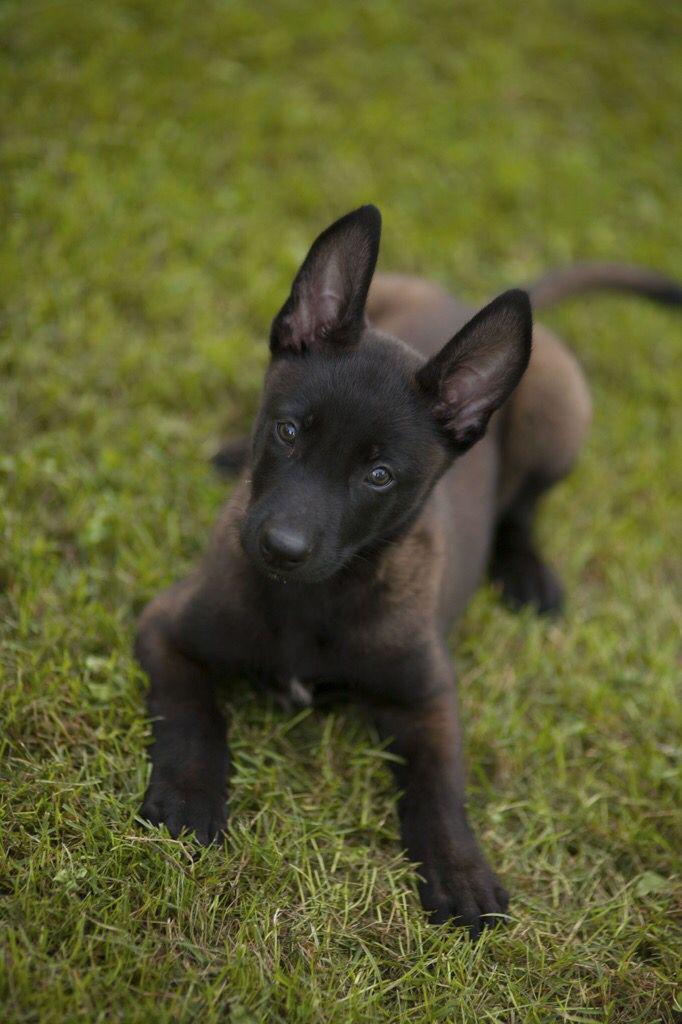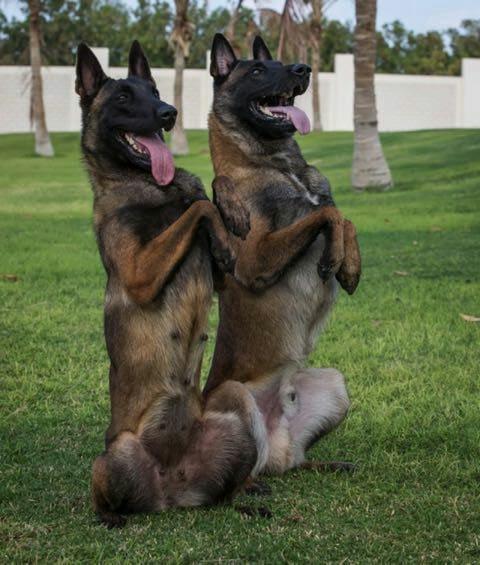The first image is the image on the left, the second image is the image on the right. Evaluate the accuracy of this statement regarding the images: "At least one of the dogs is actively moving by running, jumping, or walking.". Is it true? Answer yes or no. No. 